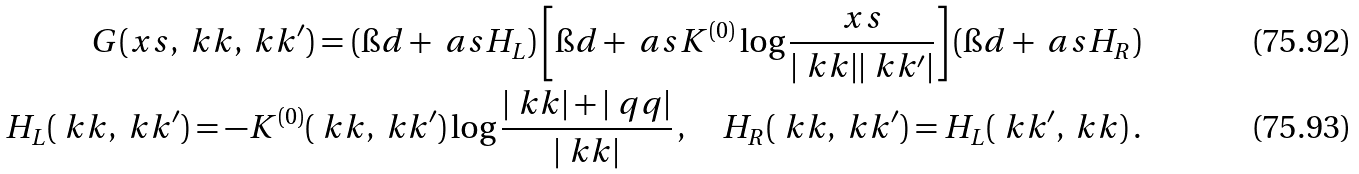<formula> <loc_0><loc_0><loc_500><loc_500>G ( x s , \ k k , \ k k ^ { \prime } ) = ( \i d + \ a s H _ { L } ) \left [ \i d + \ a s K ^ { ( 0 ) } \log \frac { x s } { | \ k k | | \ k k ^ { \prime } | } \right ] ( \i d + \ a s H _ { R } ) \\ H _ { L } ( \ k k , \ k k ^ { \prime } ) = - K ^ { ( 0 ) } ( \ k k , \ k k ^ { \prime } ) \log \frac { | \ k k | + | \ q q | } { | \ k k | } \, , \quad H _ { R } ( \ k k , \ k k ^ { \prime } ) = H _ { L } ( \ k k ^ { \prime } , \ k k ) \, .</formula> 